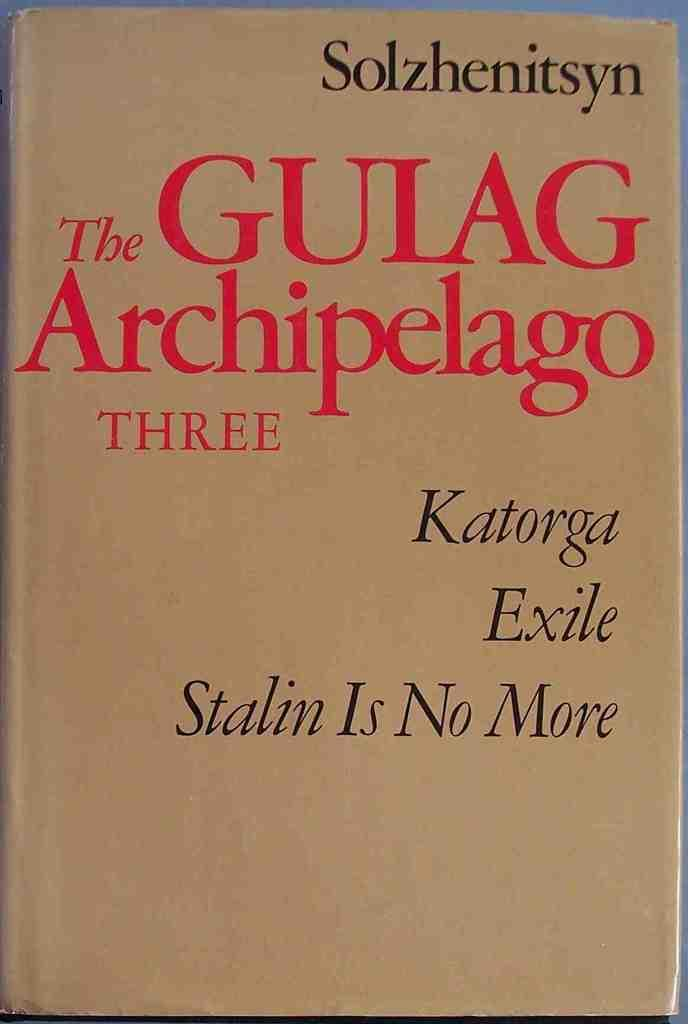<image>
Write a terse but informative summary of the picture. A book with a tan cover titled The Gulag Archipelago Three Katorga Exile Stalin Is No More. 